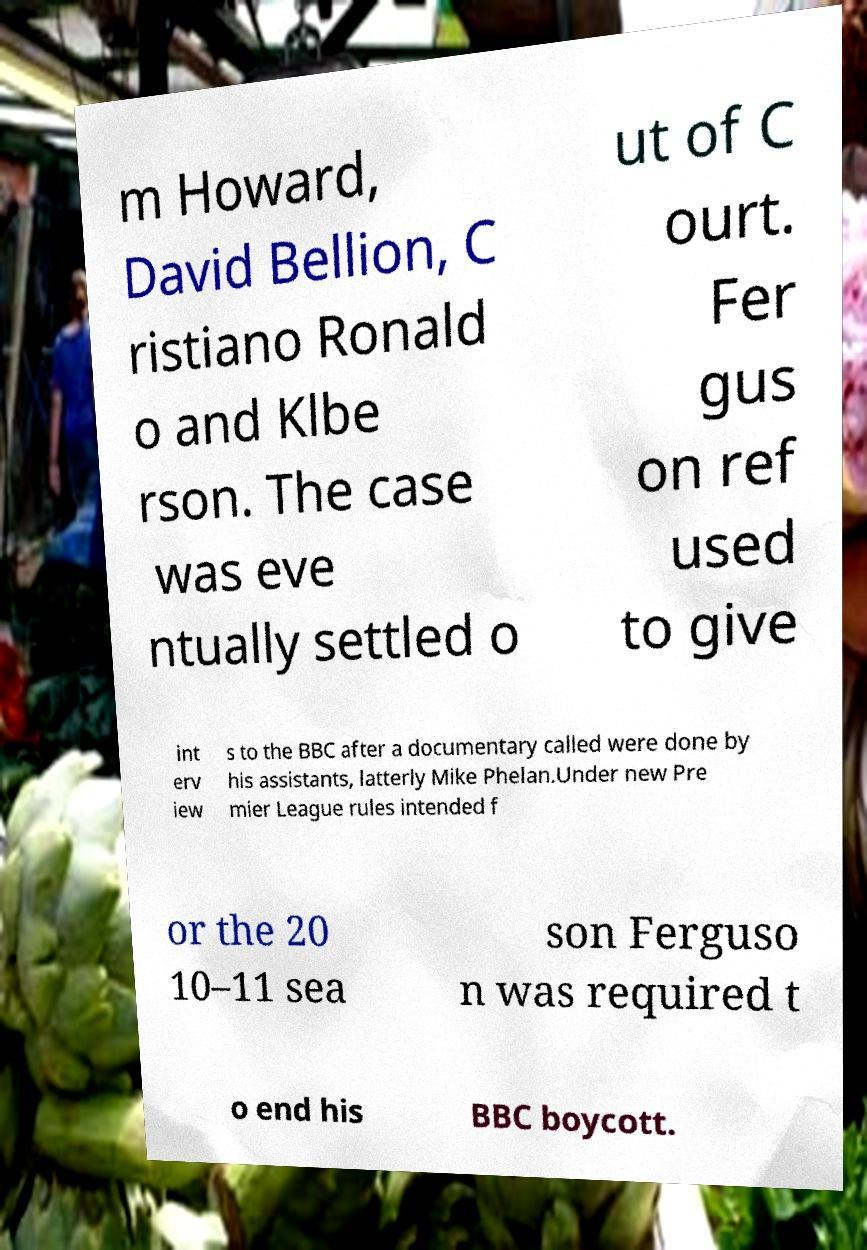Could you assist in decoding the text presented in this image and type it out clearly? m Howard, David Bellion, C ristiano Ronald o and Klbe rson. The case was eve ntually settled o ut of C ourt. Fer gus on ref used to give int erv iew s to the BBC after a documentary called were done by his assistants, latterly Mike Phelan.Under new Pre mier League rules intended f or the 20 10–11 sea son Ferguso n was required t o end his BBC boycott. 